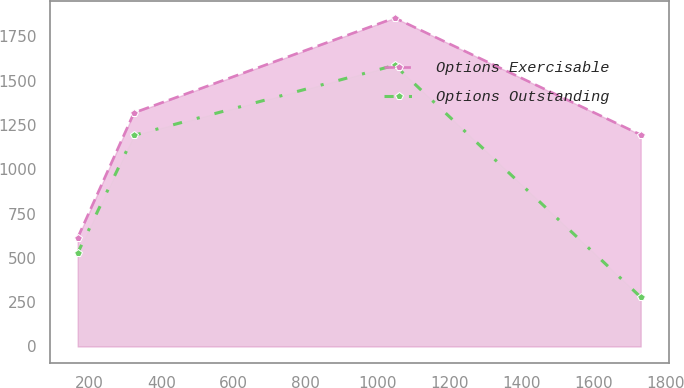Convert chart to OTSL. <chart><loc_0><loc_0><loc_500><loc_500><line_chart><ecel><fcel>Options Exercisable<fcel>Options Outstanding<nl><fcel>167.41<fcel>613.65<fcel>527.19<nl><fcel>323.74<fcel>1318.98<fcel>1191.95<nl><fcel>1048.12<fcel>1854.56<fcel>1587.37<nl><fcel>1730.75<fcel>1194.89<fcel>278.7<nl></chart> 